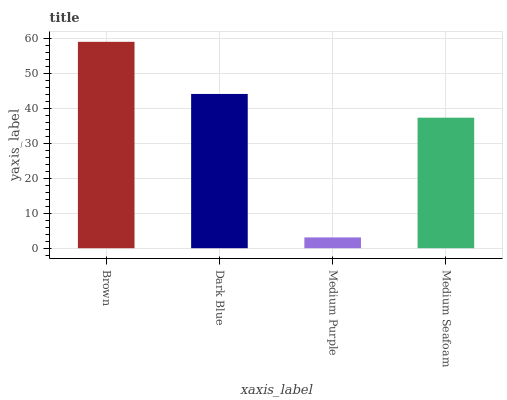Is Dark Blue the minimum?
Answer yes or no. No. Is Dark Blue the maximum?
Answer yes or no. No. Is Brown greater than Dark Blue?
Answer yes or no. Yes. Is Dark Blue less than Brown?
Answer yes or no. Yes. Is Dark Blue greater than Brown?
Answer yes or no. No. Is Brown less than Dark Blue?
Answer yes or no. No. Is Dark Blue the high median?
Answer yes or no. Yes. Is Medium Seafoam the low median?
Answer yes or no. Yes. Is Brown the high median?
Answer yes or no. No. Is Medium Purple the low median?
Answer yes or no. No. 